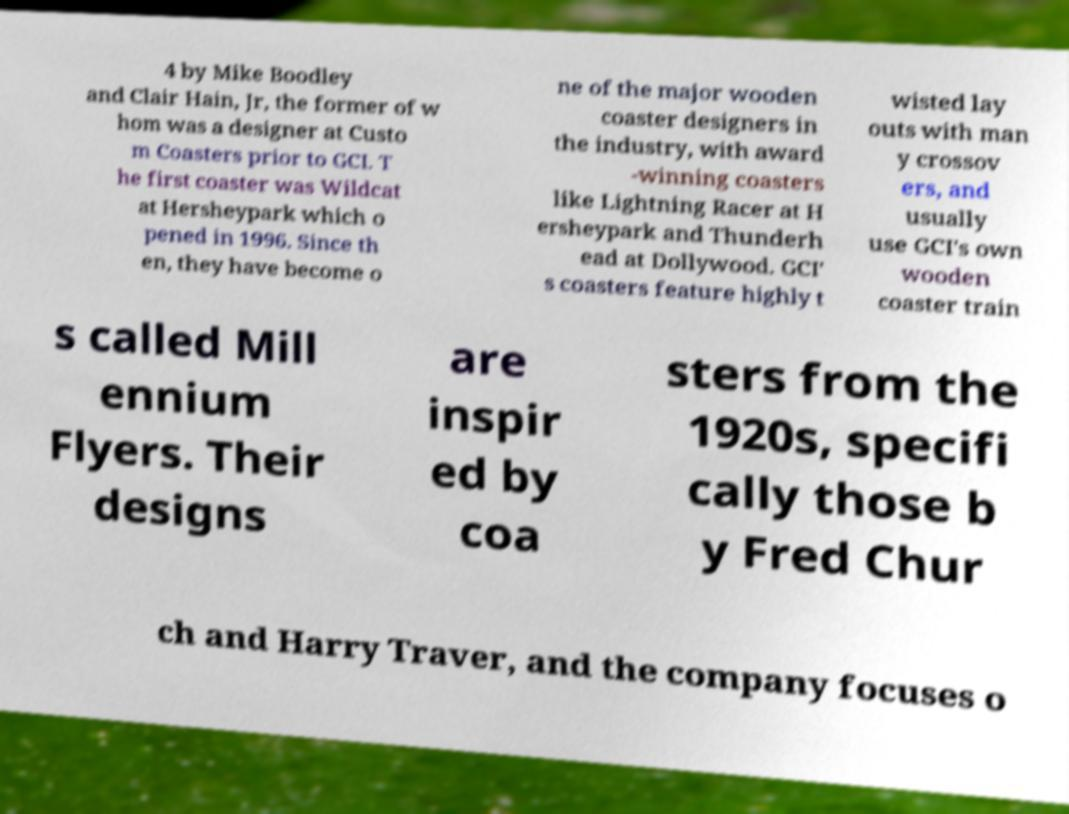Can you accurately transcribe the text from the provided image for me? 4 by Mike Boodley and Clair Hain, Jr, the former of w hom was a designer at Custo m Coasters prior to GCI. T he first coaster was Wildcat at Hersheypark which o pened in 1996. Since th en, they have become o ne of the major wooden coaster designers in the industry, with award -winning coasters like Lightning Racer at H ersheypark and Thunderh ead at Dollywood. GCI' s coasters feature highly t wisted lay outs with man y crossov ers, and usually use GCI's own wooden coaster train s called Mill ennium Flyers. Their designs are inspir ed by coa sters from the 1920s, specifi cally those b y Fred Chur ch and Harry Traver, and the company focuses o 